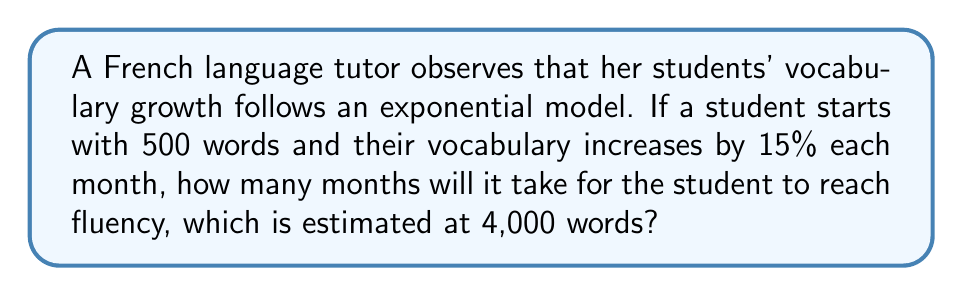Solve this math problem. Let's approach this step-by-step using an exponential growth model:

1) The exponential growth formula is:
   $A = P(1 + r)^t$
   Where:
   $A$ = final amount
   $P$ = initial amount
   $r$ = growth rate (as a decimal)
   $t$ = time (in this case, months)

2) We know:
   $P = 500$ (initial vocabulary)
   $r = 0.15$ (15% growth rate)
   $A = 4000$ (vocabulary needed for fluency)

3) Let's substitute these values into the formula:
   $4000 = 500(1 + 0.15)^t$

4) Divide both sides by 500:
   $8 = (1.15)^t$

5) Take the natural log of both sides:
   $\ln(8) = t \cdot \ln(1.15)$

6) Solve for $t$:
   $t = \frac{\ln(8)}{\ln(1.15)}$

7) Calculate:
   $t \approx 14.9149$

8) Since we can't have a fractional month, we round up to the next whole number.
Answer: 15 months 